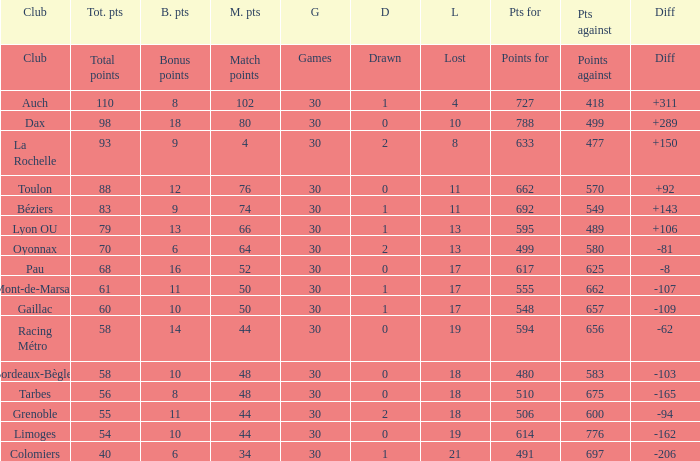What is the value of match points when the points for is 570? 76.0. 